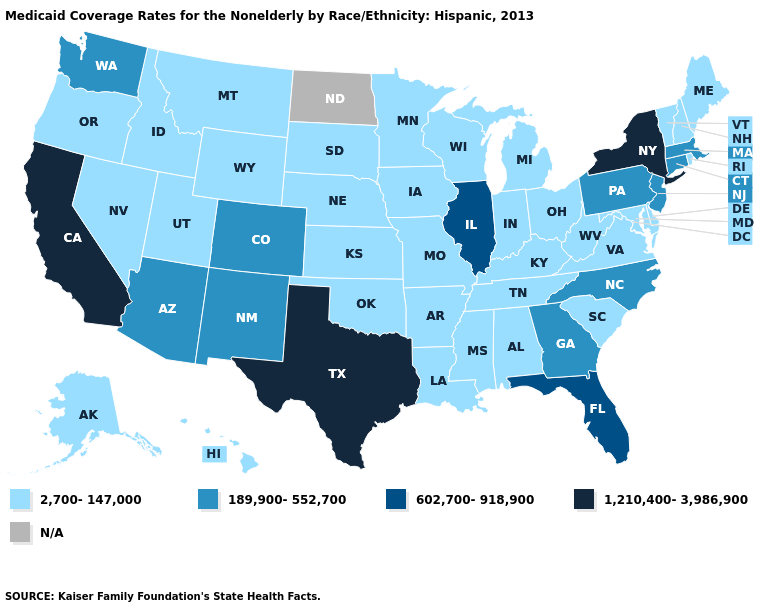Which states have the highest value in the USA?
Quick response, please. California, New York, Texas. What is the value of Georgia?
Give a very brief answer. 189,900-552,700. Which states hav the highest value in the West?
Be succinct. California. What is the value of Maine?
Answer briefly. 2,700-147,000. Name the states that have a value in the range 2,700-147,000?
Write a very short answer. Alabama, Alaska, Arkansas, Delaware, Hawaii, Idaho, Indiana, Iowa, Kansas, Kentucky, Louisiana, Maine, Maryland, Michigan, Minnesota, Mississippi, Missouri, Montana, Nebraska, Nevada, New Hampshire, Ohio, Oklahoma, Oregon, Rhode Island, South Carolina, South Dakota, Tennessee, Utah, Vermont, Virginia, West Virginia, Wisconsin, Wyoming. Name the states that have a value in the range 189,900-552,700?
Be succinct. Arizona, Colorado, Connecticut, Georgia, Massachusetts, New Jersey, New Mexico, North Carolina, Pennsylvania, Washington. What is the highest value in the South ?
Answer briefly. 1,210,400-3,986,900. What is the value of North Carolina?
Be succinct. 189,900-552,700. What is the value of West Virginia?
Quick response, please. 2,700-147,000. Among the states that border Washington , which have the highest value?
Keep it brief. Idaho, Oregon. Which states have the lowest value in the USA?
Write a very short answer. Alabama, Alaska, Arkansas, Delaware, Hawaii, Idaho, Indiana, Iowa, Kansas, Kentucky, Louisiana, Maine, Maryland, Michigan, Minnesota, Mississippi, Missouri, Montana, Nebraska, Nevada, New Hampshire, Ohio, Oklahoma, Oregon, Rhode Island, South Carolina, South Dakota, Tennessee, Utah, Vermont, Virginia, West Virginia, Wisconsin, Wyoming. Is the legend a continuous bar?
Concise answer only. No. What is the value of Maryland?
Concise answer only. 2,700-147,000. Is the legend a continuous bar?
Give a very brief answer. No. 